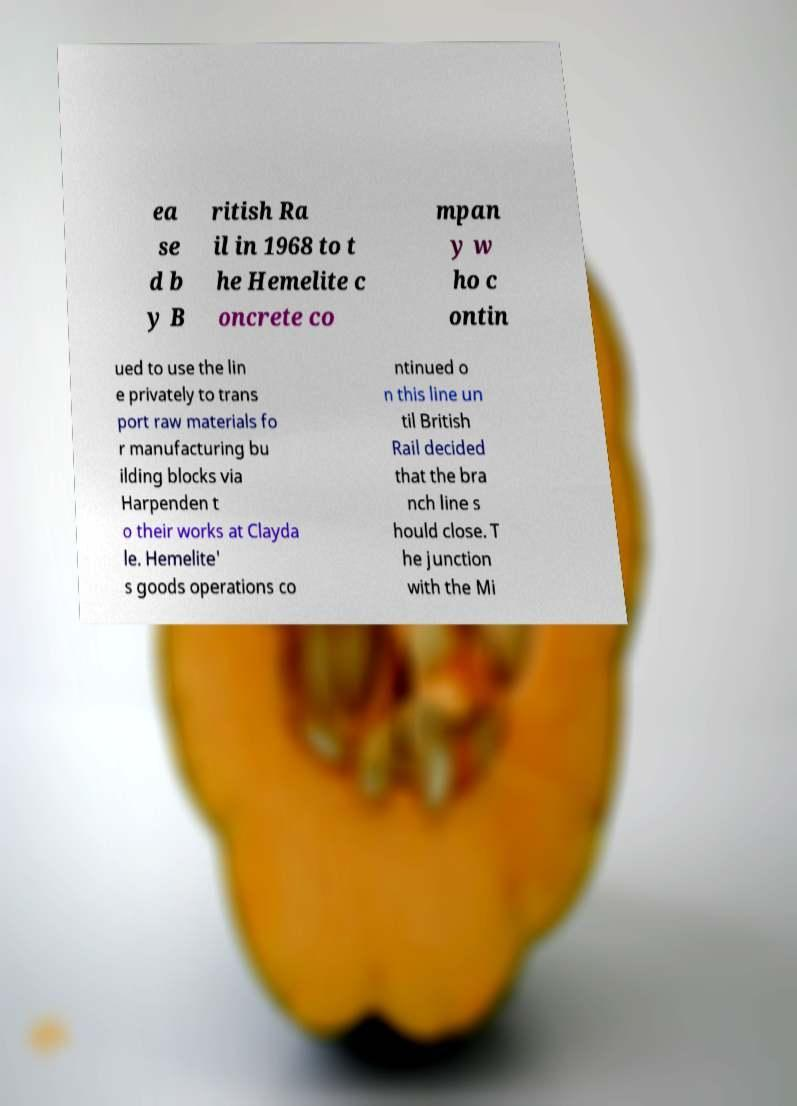Could you extract and type out the text from this image? ea se d b y B ritish Ra il in 1968 to t he Hemelite c oncrete co mpan y w ho c ontin ued to use the lin e privately to trans port raw materials fo r manufacturing bu ilding blocks via Harpenden t o their works at Clayda le. Hemelite' s goods operations co ntinued o n this line un til British Rail decided that the bra nch line s hould close. T he junction with the Mi 